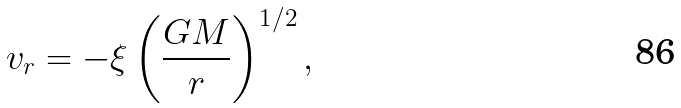<formula> <loc_0><loc_0><loc_500><loc_500>v _ { r } = - \xi \left ( \frac { G M } { r } \right ) ^ { 1 / 2 } ,</formula> 